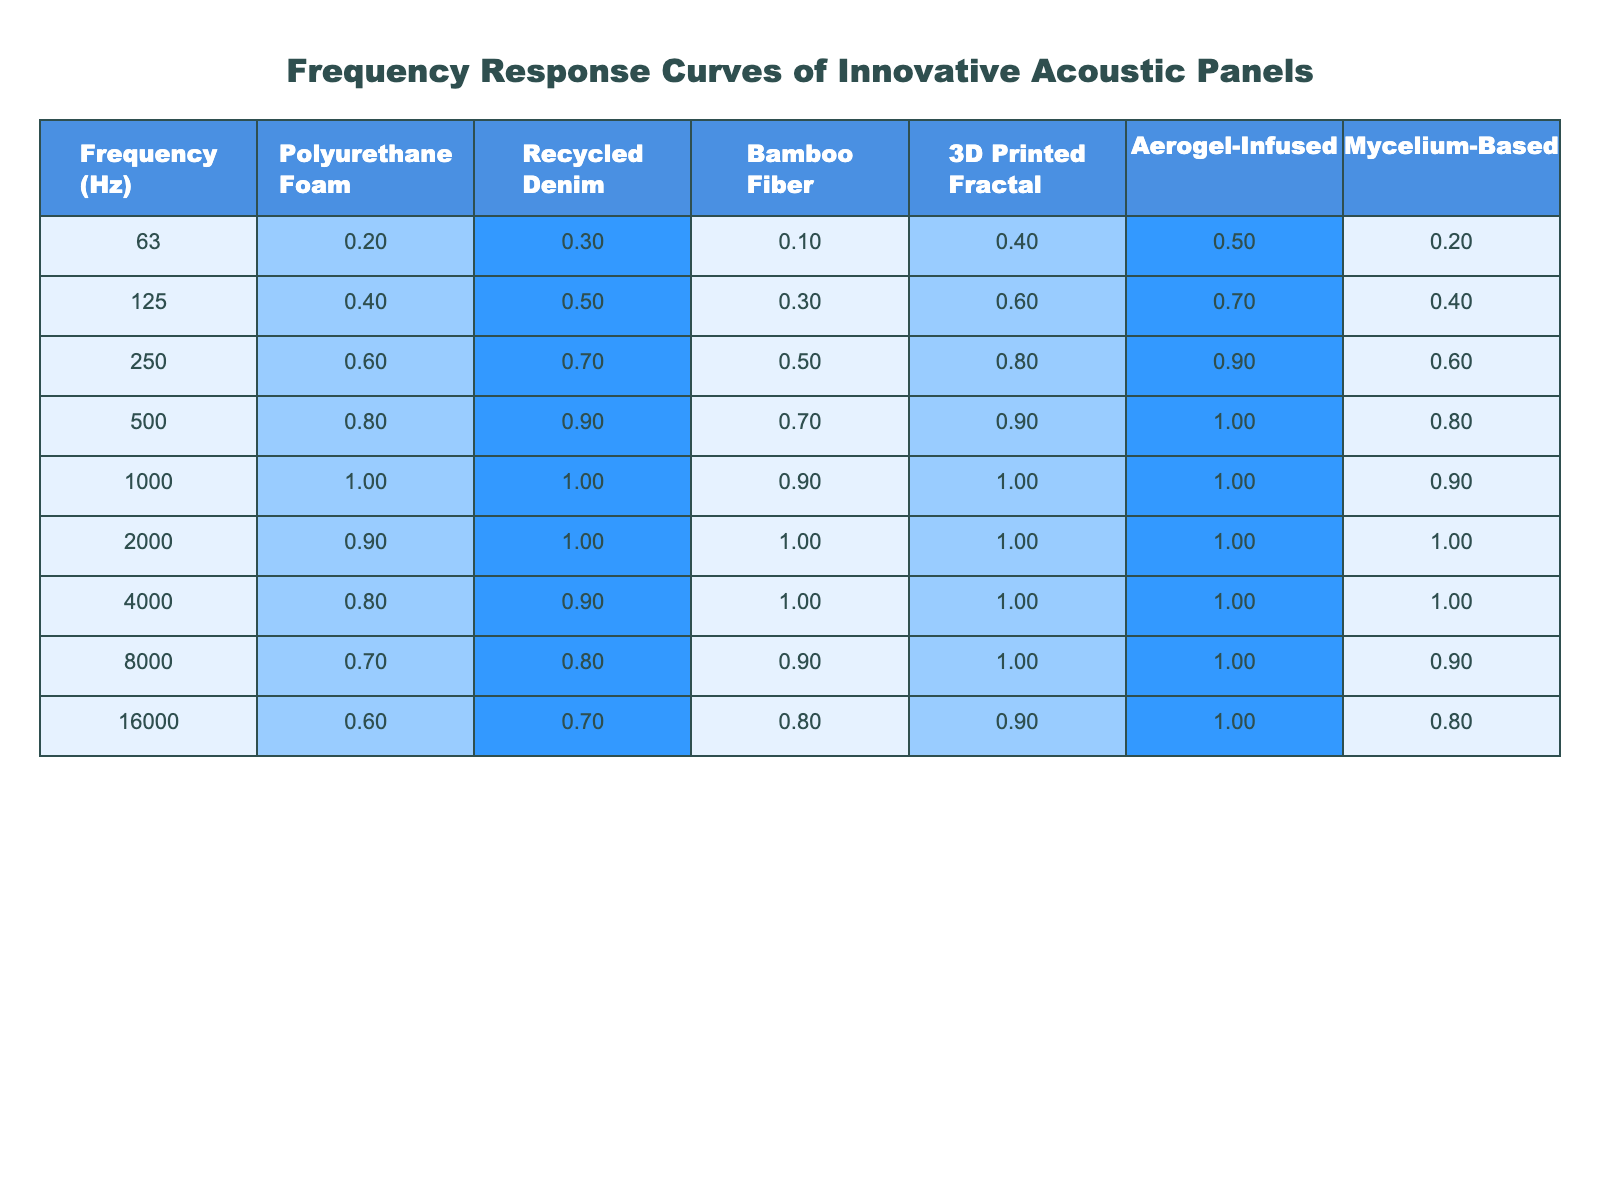What is the frequency response value for the 3D Printed Fractal panel at 500 Hz? The table shows the frequency response for the 3D Printed Fractal panel under the 500 Hz row, which has a value of 0.9.
Answer: 0.9 Which acoustic panel has the highest frequency response at 125 Hz? By comparing the values in the 125 Hz row across all panels, the Aerogel-Infused panel has the highest value of 0.7.
Answer: Aerogel-Infused What is the average frequency response for the Bamboo Fiber panel across all frequencies? To find the average, I sum the values for the Bamboo Fiber panel: (0.1 + 0.3 + 0.5 + 0.7 + 0.9 + 1.0 + 1.0 + 0.9 + 0.8) = 5.2. There are 9 frequencies, so the average is 5.2 / 9 = 0.578.
Answer: Approximately 0.58 Is the frequency response for the Mycelium-Based panel at 1000 Hz greater than or equal to 1.0? The Mycelium-Based panel has a frequency response of 0.9 at 1000 Hz, which is less than 1.0.
Answer: No What is the difference in the frequency response value between the Polyurethane Foam panel at 250 Hz and the Bamboo Fiber panel at the same frequency? The Polyurethane Foam panel has a value of 0.6 and the Bamboo Fiber panel has a value of 0.5 at 250 Hz. The difference is 0.6 - 0.5 = 0.1.
Answer: 0.1 At which frequency does the Recycled Denim panel reach its maximum frequency response? By reviewing the Recycled Denim column, its maximum response is 1.0, which occurs at both 1000 Hz and 2000 Hz.
Answer: 1000 Hz and 2000 Hz What is the total frequency response value for the Aerogel-Infused panel across all frequencies? To find the total, I sum the values of the Aerogel-Infused panel: (0.5 + 0.7 + 0.9 + 1.0 + 1.0 + 1.0 + 1.0 + 1.0) = 7.0.
Answer: 7.0 Does the frequency response for the Mycelium-Based panel increase as frequency increases from 63 Hz to 4000 Hz? By analyzing the Mycelium-Based row, the values are 0.2, 0.4, 0.6, 0.8, 0.9, 1.0, 1.0, and 0.9 respectively. The value does not consistently increase, indicating a decrease at 4000 Hz compared to the previous frequency.
Answer: No What is the lowest frequency response value achieved by the Bamboo Fiber panel? The lowest value for the Bamboo Fiber panel is observed at 63 Hz with a value of 0.1.
Answer: 0.1 What pattern is observed in the frequency responses of the innovative acoustic panels as the frequency increases? The majority of panels show a rising trend in frequency response values up to 2000 Hz, followed by a slight decrease at 4000 Hz and 8000 Hz for some panels.
Answer: Generally rising then slight decrease 